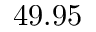Convert formula to latex. <formula><loc_0><loc_0><loc_500><loc_500>4 9 . 9 5</formula> 